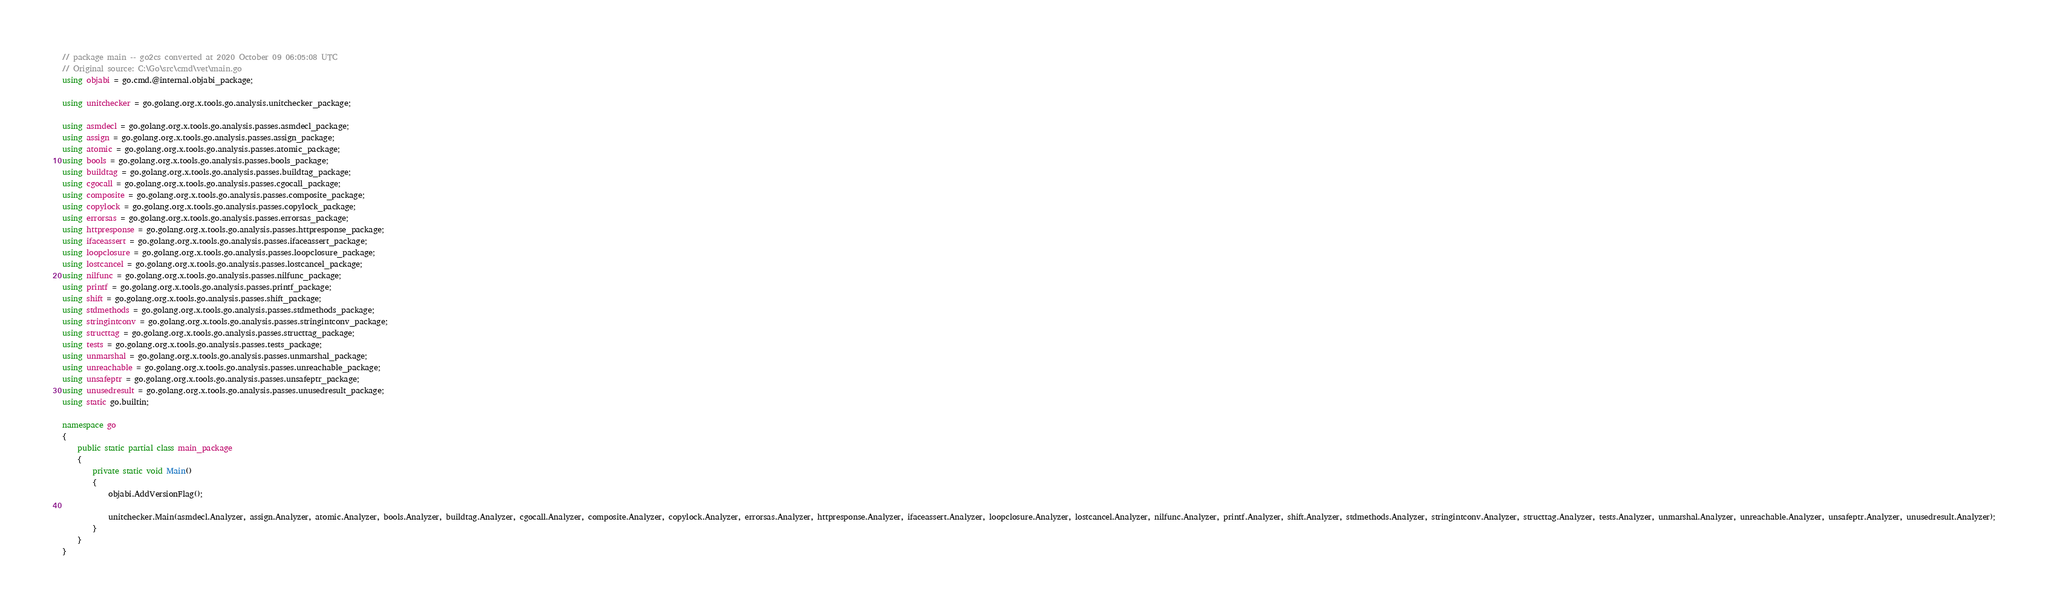Convert code to text. <code><loc_0><loc_0><loc_500><loc_500><_C#_>// package main -- go2cs converted at 2020 October 09 06:05:08 UTC
// Original source: C:\Go\src\cmd\vet\main.go
using objabi = go.cmd.@internal.objabi_package;

using unitchecker = go.golang.org.x.tools.go.analysis.unitchecker_package;

using asmdecl = go.golang.org.x.tools.go.analysis.passes.asmdecl_package;
using assign = go.golang.org.x.tools.go.analysis.passes.assign_package;
using atomic = go.golang.org.x.tools.go.analysis.passes.atomic_package;
using bools = go.golang.org.x.tools.go.analysis.passes.bools_package;
using buildtag = go.golang.org.x.tools.go.analysis.passes.buildtag_package;
using cgocall = go.golang.org.x.tools.go.analysis.passes.cgocall_package;
using composite = go.golang.org.x.tools.go.analysis.passes.composite_package;
using copylock = go.golang.org.x.tools.go.analysis.passes.copylock_package;
using errorsas = go.golang.org.x.tools.go.analysis.passes.errorsas_package;
using httpresponse = go.golang.org.x.tools.go.analysis.passes.httpresponse_package;
using ifaceassert = go.golang.org.x.tools.go.analysis.passes.ifaceassert_package;
using loopclosure = go.golang.org.x.tools.go.analysis.passes.loopclosure_package;
using lostcancel = go.golang.org.x.tools.go.analysis.passes.lostcancel_package;
using nilfunc = go.golang.org.x.tools.go.analysis.passes.nilfunc_package;
using printf = go.golang.org.x.tools.go.analysis.passes.printf_package;
using shift = go.golang.org.x.tools.go.analysis.passes.shift_package;
using stdmethods = go.golang.org.x.tools.go.analysis.passes.stdmethods_package;
using stringintconv = go.golang.org.x.tools.go.analysis.passes.stringintconv_package;
using structtag = go.golang.org.x.tools.go.analysis.passes.structtag_package;
using tests = go.golang.org.x.tools.go.analysis.passes.tests_package;
using unmarshal = go.golang.org.x.tools.go.analysis.passes.unmarshal_package;
using unreachable = go.golang.org.x.tools.go.analysis.passes.unreachable_package;
using unsafeptr = go.golang.org.x.tools.go.analysis.passes.unsafeptr_package;
using unusedresult = go.golang.org.x.tools.go.analysis.passes.unusedresult_package;
using static go.builtin;

namespace go
{
    public static partial class main_package
    {
        private static void Main()
        {
            objabi.AddVersionFlag();

            unitchecker.Main(asmdecl.Analyzer, assign.Analyzer, atomic.Analyzer, bools.Analyzer, buildtag.Analyzer, cgocall.Analyzer, composite.Analyzer, copylock.Analyzer, errorsas.Analyzer, httpresponse.Analyzer, ifaceassert.Analyzer, loopclosure.Analyzer, lostcancel.Analyzer, nilfunc.Analyzer, printf.Analyzer, shift.Analyzer, stdmethods.Analyzer, stringintconv.Analyzer, structtag.Analyzer, tests.Analyzer, unmarshal.Analyzer, unreachable.Analyzer, unsafeptr.Analyzer, unusedresult.Analyzer);
        }
    }
}
</code> 